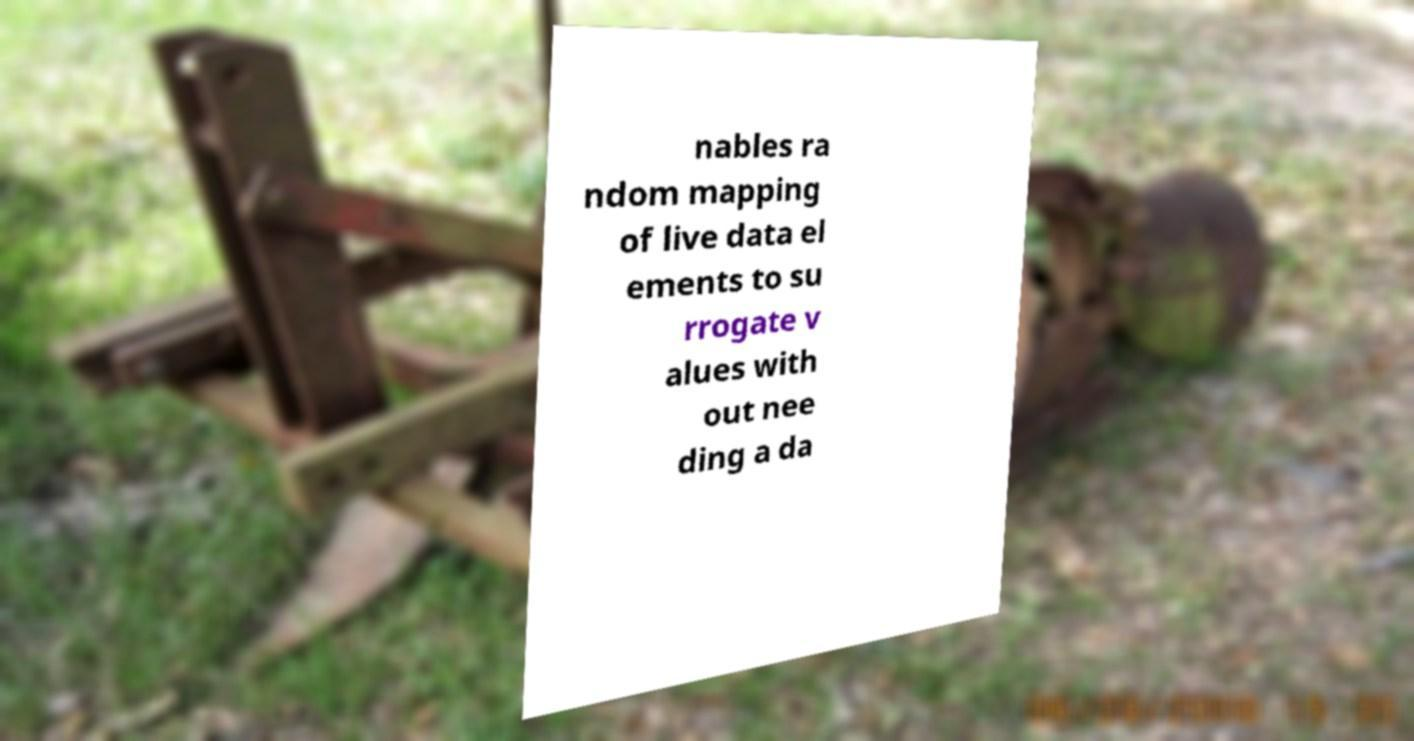Please identify and transcribe the text found in this image. nables ra ndom mapping of live data el ements to su rrogate v alues with out nee ding a da 